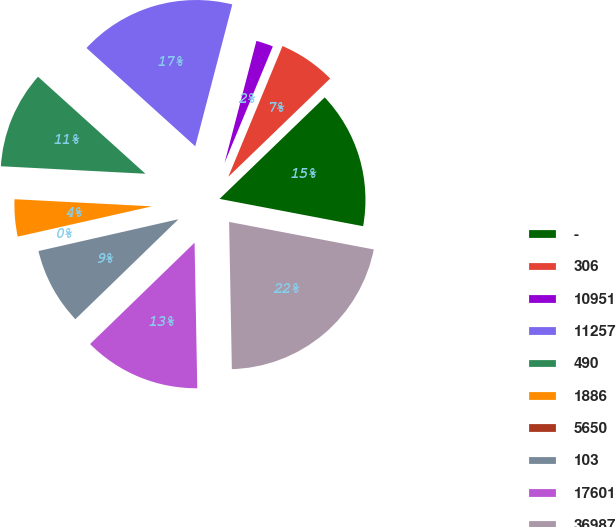<chart> <loc_0><loc_0><loc_500><loc_500><pie_chart><fcel>-<fcel>306<fcel>10951<fcel>11257<fcel>490<fcel>1886<fcel>5650<fcel>103<fcel>17601<fcel>36987<nl><fcel>15.21%<fcel>6.53%<fcel>2.19%<fcel>17.37%<fcel>10.87%<fcel>4.36%<fcel>0.02%<fcel>8.7%<fcel>13.04%<fcel>21.71%<nl></chart> 